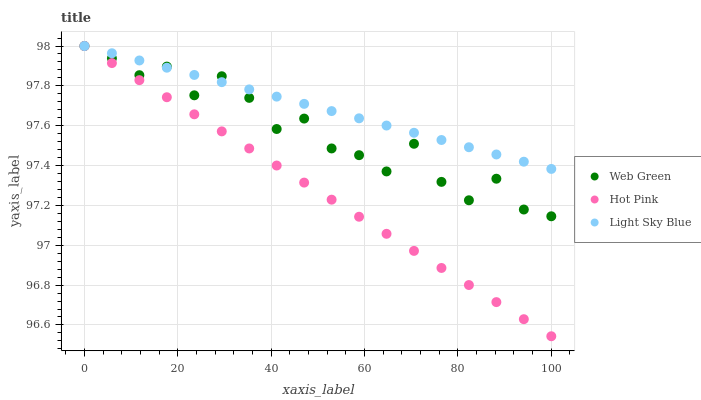Does Hot Pink have the minimum area under the curve?
Answer yes or no. Yes. Does Light Sky Blue have the maximum area under the curve?
Answer yes or no. Yes. Does Web Green have the minimum area under the curve?
Answer yes or no. No. Does Web Green have the maximum area under the curve?
Answer yes or no. No. Is Hot Pink the smoothest?
Answer yes or no. Yes. Is Web Green the roughest?
Answer yes or no. Yes. Is Light Sky Blue the smoothest?
Answer yes or no. No. Is Light Sky Blue the roughest?
Answer yes or no. No. Does Hot Pink have the lowest value?
Answer yes or no. Yes. Does Web Green have the lowest value?
Answer yes or no. No. Does Light Sky Blue have the highest value?
Answer yes or no. Yes. Does Light Sky Blue intersect Hot Pink?
Answer yes or no. Yes. Is Light Sky Blue less than Hot Pink?
Answer yes or no. No. Is Light Sky Blue greater than Hot Pink?
Answer yes or no. No. 